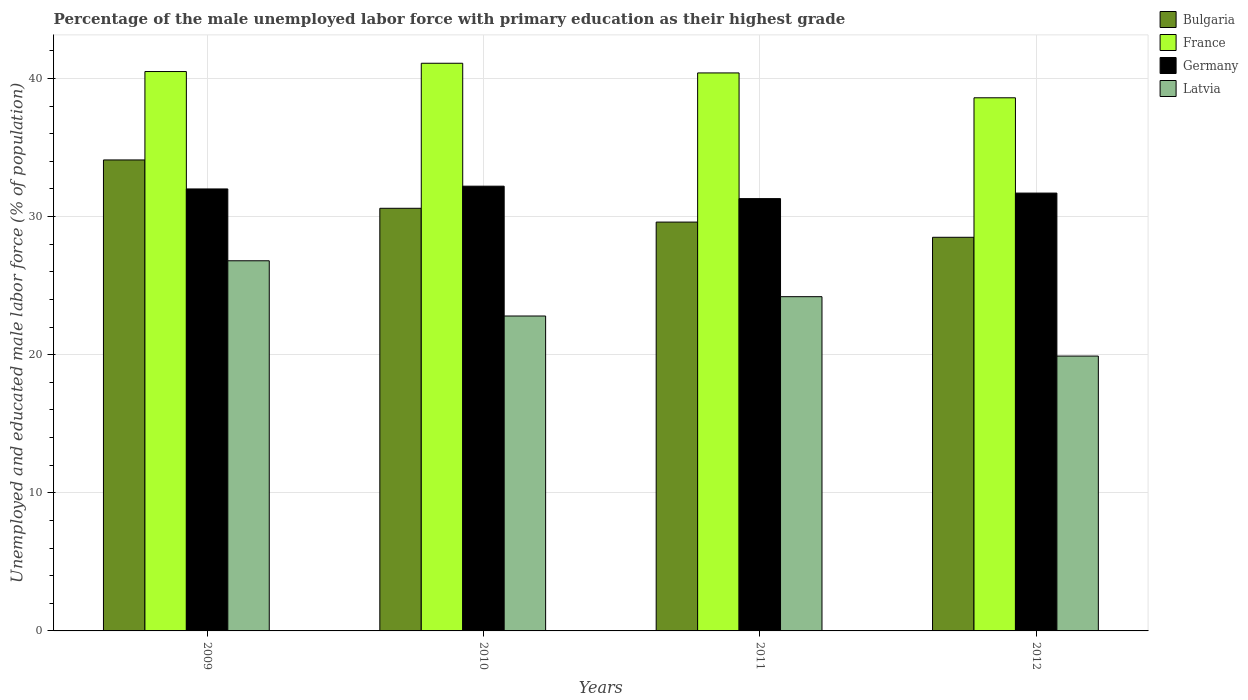How many different coloured bars are there?
Give a very brief answer. 4. How many bars are there on the 1st tick from the right?
Your response must be concise. 4. What is the percentage of the unemployed male labor force with primary education in Latvia in 2012?
Provide a short and direct response. 19.9. Across all years, what is the maximum percentage of the unemployed male labor force with primary education in Latvia?
Provide a short and direct response. 26.8. Across all years, what is the minimum percentage of the unemployed male labor force with primary education in Bulgaria?
Your answer should be compact. 28.5. What is the total percentage of the unemployed male labor force with primary education in Bulgaria in the graph?
Make the answer very short. 122.8. What is the difference between the percentage of the unemployed male labor force with primary education in France in 2010 and that in 2012?
Your answer should be very brief. 2.5. What is the difference between the percentage of the unemployed male labor force with primary education in Bulgaria in 2009 and the percentage of the unemployed male labor force with primary education in Latvia in 2012?
Make the answer very short. 14.2. What is the average percentage of the unemployed male labor force with primary education in Latvia per year?
Ensure brevity in your answer.  23.42. In the year 2011, what is the difference between the percentage of the unemployed male labor force with primary education in Germany and percentage of the unemployed male labor force with primary education in Latvia?
Offer a very short reply. 7.1. What is the ratio of the percentage of the unemployed male labor force with primary education in Germany in 2010 to that in 2011?
Offer a very short reply. 1.03. What is the difference between the highest and the second highest percentage of the unemployed male labor force with primary education in Latvia?
Provide a succinct answer. 2.6. What is the difference between the highest and the lowest percentage of the unemployed male labor force with primary education in Germany?
Offer a very short reply. 0.9. Is the sum of the percentage of the unemployed male labor force with primary education in France in 2010 and 2011 greater than the maximum percentage of the unemployed male labor force with primary education in Bulgaria across all years?
Give a very brief answer. Yes. Is it the case that in every year, the sum of the percentage of the unemployed male labor force with primary education in Bulgaria and percentage of the unemployed male labor force with primary education in Germany is greater than the sum of percentage of the unemployed male labor force with primary education in Latvia and percentage of the unemployed male labor force with primary education in France?
Make the answer very short. Yes. What does the 4th bar from the left in 2010 represents?
Provide a short and direct response. Latvia. What does the 1st bar from the right in 2009 represents?
Give a very brief answer. Latvia. Is it the case that in every year, the sum of the percentage of the unemployed male labor force with primary education in Bulgaria and percentage of the unemployed male labor force with primary education in France is greater than the percentage of the unemployed male labor force with primary education in Latvia?
Make the answer very short. Yes. How many bars are there?
Your response must be concise. 16. What is the difference between two consecutive major ticks on the Y-axis?
Your answer should be very brief. 10. Are the values on the major ticks of Y-axis written in scientific E-notation?
Your response must be concise. No. Does the graph contain grids?
Provide a succinct answer. Yes. Where does the legend appear in the graph?
Keep it short and to the point. Top right. What is the title of the graph?
Offer a very short reply. Percentage of the male unemployed labor force with primary education as their highest grade. What is the label or title of the X-axis?
Provide a succinct answer. Years. What is the label or title of the Y-axis?
Keep it short and to the point. Unemployed and educated male labor force (% of population). What is the Unemployed and educated male labor force (% of population) of Bulgaria in 2009?
Provide a short and direct response. 34.1. What is the Unemployed and educated male labor force (% of population) in France in 2009?
Make the answer very short. 40.5. What is the Unemployed and educated male labor force (% of population) of Latvia in 2009?
Your answer should be very brief. 26.8. What is the Unemployed and educated male labor force (% of population) of Bulgaria in 2010?
Offer a terse response. 30.6. What is the Unemployed and educated male labor force (% of population) of France in 2010?
Keep it short and to the point. 41.1. What is the Unemployed and educated male labor force (% of population) of Germany in 2010?
Provide a short and direct response. 32.2. What is the Unemployed and educated male labor force (% of population) of Latvia in 2010?
Offer a terse response. 22.8. What is the Unemployed and educated male labor force (% of population) of Bulgaria in 2011?
Your answer should be very brief. 29.6. What is the Unemployed and educated male labor force (% of population) of France in 2011?
Provide a succinct answer. 40.4. What is the Unemployed and educated male labor force (% of population) in Germany in 2011?
Give a very brief answer. 31.3. What is the Unemployed and educated male labor force (% of population) of Latvia in 2011?
Your answer should be very brief. 24.2. What is the Unemployed and educated male labor force (% of population) in Bulgaria in 2012?
Your answer should be very brief. 28.5. What is the Unemployed and educated male labor force (% of population) in France in 2012?
Keep it short and to the point. 38.6. What is the Unemployed and educated male labor force (% of population) of Germany in 2012?
Keep it short and to the point. 31.7. What is the Unemployed and educated male labor force (% of population) in Latvia in 2012?
Your response must be concise. 19.9. Across all years, what is the maximum Unemployed and educated male labor force (% of population) of Bulgaria?
Provide a short and direct response. 34.1. Across all years, what is the maximum Unemployed and educated male labor force (% of population) in France?
Make the answer very short. 41.1. Across all years, what is the maximum Unemployed and educated male labor force (% of population) in Germany?
Provide a short and direct response. 32.2. Across all years, what is the maximum Unemployed and educated male labor force (% of population) in Latvia?
Make the answer very short. 26.8. Across all years, what is the minimum Unemployed and educated male labor force (% of population) in France?
Give a very brief answer. 38.6. Across all years, what is the minimum Unemployed and educated male labor force (% of population) in Germany?
Your answer should be very brief. 31.3. Across all years, what is the minimum Unemployed and educated male labor force (% of population) of Latvia?
Your response must be concise. 19.9. What is the total Unemployed and educated male labor force (% of population) in Bulgaria in the graph?
Your answer should be very brief. 122.8. What is the total Unemployed and educated male labor force (% of population) in France in the graph?
Offer a terse response. 160.6. What is the total Unemployed and educated male labor force (% of population) of Germany in the graph?
Your answer should be very brief. 127.2. What is the total Unemployed and educated male labor force (% of population) of Latvia in the graph?
Your answer should be very brief. 93.7. What is the difference between the Unemployed and educated male labor force (% of population) of Latvia in 2009 and that in 2010?
Ensure brevity in your answer.  4. What is the difference between the Unemployed and educated male labor force (% of population) of Bulgaria in 2009 and that in 2011?
Your answer should be compact. 4.5. What is the difference between the Unemployed and educated male labor force (% of population) in France in 2009 and that in 2011?
Your response must be concise. 0.1. What is the difference between the Unemployed and educated male labor force (% of population) in Germany in 2009 and that in 2011?
Your answer should be very brief. 0.7. What is the difference between the Unemployed and educated male labor force (% of population) in Latvia in 2009 and that in 2011?
Offer a very short reply. 2.6. What is the difference between the Unemployed and educated male labor force (% of population) of Bulgaria in 2009 and that in 2012?
Your answer should be compact. 5.6. What is the difference between the Unemployed and educated male labor force (% of population) in France in 2009 and that in 2012?
Ensure brevity in your answer.  1.9. What is the difference between the Unemployed and educated male labor force (% of population) in Germany in 2009 and that in 2012?
Your answer should be very brief. 0.3. What is the difference between the Unemployed and educated male labor force (% of population) in Latvia in 2009 and that in 2012?
Ensure brevity in your answer.  6.9. What is the difference between the Unemployed and educated male labor force (% of population) of Bulgaria in 2010 and that in 2011?
Your answer should be very brief. 1. What is the difference between the Unemployed and educated male labor force (% of population) in Germany in 2010 and that in 2011?
Provide a succinct answer. 0.9. What is the difference between the Unemployed and educated male labor force (% of population) in Latvia in 2010 and that in 2011?
Your answer should be very brief. -1.4. What is the difference between the Unemployed and educated male labor force (% of population) of France in 2010 and that in 2012?
Your response must be concise. 2.5. What is the difference between the Unemployed and educated male labor force (% of population) of Bulgaria in 2011 and that in 2012?
Give a very brief answer. 1.1. What is the difference between the Unemployed and educated male labor force (% of population) of Germany in 2011 and that in 2012?
Make the answer very short. -0.4. What is the difference between the Unemployed and educated male labor force (% of population) in Bulgaria in 2009 and the Unemployed and educated male labor force (% of population) in Germany in 2010?
Provide a succinct answer. 1.9. What is the difference between the Unemployed and educated male labor force (% of population) of Bulgaria in 2009 and the Unemployed and educated male labor force (% of population) of Latvia in 2010?
Your response must be concise. 11.3. What is the difference between the Unemployed and educated male labor force (% of population) in France in 2009 and the Unemployed and educated male labor force (% of population) in Latvia in 2010?
Provide a succinct answer. 17.7. What is the difference between the Unemployed and educated male labor force (% of population) in Bulgaria in 2009 and the Unemployed and educated male labor force (% of population) in France in 2011?
Keep it short and to the point. -6.3. What is the difference between the Unemployed and educated male labor force (% of population) of Bulgaria in 2009 and the Unemployed and educated male labor force (% of population) of Germany in 2011?
Ensure brevity in your answer.  2.8. What is the difference between the Unemployed and educated male labor force (% of population) of Bulgaria in 2009 and the Unemployed and educated male labor force (% of population) of Latvia in 2011?
Ensure brevity in your answer.  9.9. What is the difference between the Unemployed and educated male labor force (% of population) of France in 2009 and the Unemployed and educated male labor force (% of population) of Germany in 2011?
Offer a very short reply. 9.2. What is the difference between the Unemployed and educated male labor force (% of population) of Bulgaria in 2009 and the Unemployed and educated male labor force (% of population) of Latvia in 2012?
Your answer should be compact. 14.2. What is the difference between the Unemployed and educated male labor force (% of population) in France in 2009 and the Unemployed and educated male labor force (% of population) in Germany in 2012?
Make the answer very short. 8.8. What is the difference between the Unemployed and educated male labor force (% of population) in France in 2009 and the Unemployed and educated male labor force (% of population) in Latvia in 2012?
Ensure brevity in your answer.  20.6. What is the difference between the Unemployed and educated male labor force (% of population) in Bulgaria in 2010 and the Unemployed and educated male labor force (% of population) in Germany in 2011?
Your answer should be compact. -0.7. What is the difference between the Unemployed and educated male labor force (% of population) of Bulgaria in 2010 and the Unemployed and educated male labor force (% of population) of Latvia in 2011?
Ensure brevity in your answer.  6.4. What is the difference between the Unemployed and educated male labor force (% of population) of France in 2010 and the Unemployed and educated male labor force (% of population) of Germany in 2011?
Keep it short and to the point. 9.8. What is the difference between the Unemployed and educated male labor force (% of population) in France in 2010 and the Unemployed and educated male labor force (% of population) in Latvia in 2011?
Offer a very short reply. 16.9. What is the difference between the Unemployed and educated male labor force (% of population) in Germany in 2010 and the Unemployed and educated male labor force (% of population) in Latvia in 2011?
Give a very brief answer. 8. What is the difference between the Unemployed and educated male labor force (% of population) of Bulgaria in 2010 and the Unemployed and educated male labor force (% of population) of France in 2012?
Make the answer very short. -8. What is the difference between the Unemployed and educated male labor force (% of population) of Bulgaria in 2010 and the Unemployed and educated male labor force (% of population) of Latvia in 2012?
Provide a short and direct response. 10.7. What is the difference between the Unemployed and educated male labor force (% of population) of France in 2010 and the Unemployed and educated male labor force (% of population) of Latvia in 2012?
Your answer should be compact. 21.2. What is the difference between the Unemployed and educated male labor force (% of population) of Germany in 2010 and the Unemployed and educated male labor force (% of population) of Latvia in 2012?
Your answer should be compact. 12.3. What is the difference between the Unemployed and educated male labor force (% of population) of Bulgaria in 2011 and the Unemployed and educated male labor force (% of population) of France in 2012?
Your answer should be very brief. -9. What is the difference between the Unemployed and educated male labor force (% of population) of Bulgaria in 2011 and the Unemployed and educated male labor force (% of population) of Germany in 2012?
Give a very brief answer. -2.1. What is the difference between the Unemployed and educated male labor force (% of population) of Germany in 2011 and the Unemployed and educated male labor force (% of population) of Latvia in 2012?
Give a very brief answer. 11.4. What is the average Unemployed and educated male labor force (% of population) in Bulgaria per year?
Give a very brief answer. 30.7. What is the average Unemployed and educated male labor force (% of population) in France per year?
Ensure brevity in your answer.  40.15. What is the average Unemployed and educated male labor force (% of population) in Germany per year?
Your answer should be very brief. 31.8. What is the average Unemployed and educated male labor force (% of population) in Latvia per year?
Your response must be concise. 23.43. In the year 2009, what is the difference between the Unemployed and educated male labor force (% of population) in Bulgaria and Unemployed and educated male labor force (% of population) in France?
Your answer should be compact. -6.4. In the year 2009, what is the difference between the Unemployed and educated male labor force (% of population) in Bulgaria and Unemployed and educated male labor force (% of population) in Germany?
Your answer should be very brief. 2.1. In the year 2009, what is the difference between the Unemployed and educated male labor force (% of population) of Bulgaria and Unemployed and educated male labor force (% of population) of Latvia?
Your answer should be very brief. 7.3. In the year 2010, what is the difference between the Unemployed and educated male labor force (% of population) of Bulgaria and Unemployed and educated male labor force (% of population) of France?
Give a very brief answer. -10.5. In the year 2010, what is the difference between the Unemployed and educated male labor force (% of population) of Bulgaria and Unemployed and educated male labor force (% of population) of Latvia?
Your answer should be compact. 7.8. In the year 2012, what is the difference between the Unemployed and educated male labor force (% of population) of Bulgaria and Unemployed and educated male labor force (% of population) of Germany?
Keep it short and to the point. -3.2. In the year 2012, what is the difference between the Unemployed and educated male labor force (% of population) in Germany and Unemployed and educated male labor force (% of population) in Latvia?
Provide a short and direct response. 11.8. What is the ratio of the Unemployed and educated male labor force (% of population) of Bulgaria in 2009 to that in 2010?
Your answer should be compact. 1.11. What is the ratio of the Unemployed and educated male labor force (% of population) in France in 2009 to that in 2010?
Provide a succinct answer. 0.99. What is the ratio of the Unemployed and educated male labor force (% of population) of Germany in 2009 to that in 2010?
Ensure brevity in your answer.  0.99. What is the ratio of the Unemployed and educated male labor force (% of population) in Latvia in 2009 to that in 2010?
Provide a succinct answer. 1.18. What is the ratio of the Unemployed and educated male labor force (% of population) in Bulgaria in 2009 to that in 2011?
Offer a very short reply. 1.15. What is the ratio of the Unemployed and educated male labor force (% of population) of France in 2009 to that in 2011?
Give a very brief answer. 1. What is the ratio of the Unemployed and educated male labor force (% of population) of Germany in 2009 to that in 2011?
Make the answer very short. 1.02. What is the ratio of the Unemployed and educated male labor force (% of population) of Latvia in 2009 to that in 2011?
Your response must be concise. 1.11. What is the ratio of the Unemployed and educated male labor force (% of population) of Bulgaria in 2009 to that in 2012?
Offer a terse response. 1.2. What is the ratio of the Unemployed and educated male labor force (% of population) in France in 2009 to that in 2012?
Make the answer very short. 1.05. What is the ratio of the Unemployed and educated male labor force (% of population) of Germany in 2009 to that in 2012?
Offer a terse response. 1.01. What is the ratio of the Unemployed and educated male labor force (% of population) in Latvia in 2009 to that in 2012?
Offer a terse response. 1.35. What is the ratio of the Unemployed and educated male labor force (% of population) in Bulgaria in 2010 to that in 2011?
Your response must be concise. 1.03. What is the ratio of the Unemployed and educated male labor force (% of population) in France in 2010 to that in 2011?
Provide a short and direct response. 1.02. What is the ratio of the Unemployed and educated male labor force (% of population) of Germany in 2010 to that in 2011?
Ensure brevity in your answer.  1.03. What is the ratio of the Unemployed and educated male labor force (% of population) in Latvia in 2010 to that in 2011?
Offer a terse response. 0.94. What is the ratio of the Unemployed and educated male labor force (% of population) of Bulgaria in 2010 to that in 2012?
Make the answer very short. 1.07. What is the ratio of the Unemployed and educated male labor force (% of population) in France in 2010 to that in 2012?
Provide a succinct answer. 1.06. What is the ratio of the Unemployed and educated male labor force (% of population) of Germany in 2010 to that in 2012?
Make the answer very short. 1.02. What is the ratio of the Unemployed and educated male labor force (% of population) in Latvia in 2010 to that in 2012?
Your response must be concise. 1.15. What is the ratio of the Unemployed and educated male labor force (% of population) in Bulgaria in 2011 to that in 2012?
Offer a terse response. 1.04. What is the ratio of the Unemployed and educated male labor force (% of population) in France in 2011 to that in 2012?
Offer a terse response. 1.05. What is the ratio of the Unemployed and educated male labor force (% of population) in Germany in 2011 to that in 2012?
Ensure brevity in your answer.  0.99. What is the ratio of the Unemployed and educated male labor force (% of population) of Latvia in 2011 to that in 2012?
Your answer should be compact. 1.22. What is the difference between the highest and the second highest Unemployed and educated male labor force (% of population) of Bulgaria?
Make the answer very short. 3.5. What is the difference between the highest and the second highest Unemployed and educated male labor force (% of population) in Latvia?
Give a very brief answer. 2.6. What is the difference between the highest and the lowest Unemployed and educated male labor force (% of population) in Bulgaria?
Provide a succinct answer. 5.6. What is the difference between the highest and the lowest Unemployed and educated male labor force (% of population) in France?
Offer a terse response. 2.5. What is the difference between the highest and the lowest Unemployed and educated male labor force (% of population) in Latvia?
Provide a succinct answer. 6.9. 